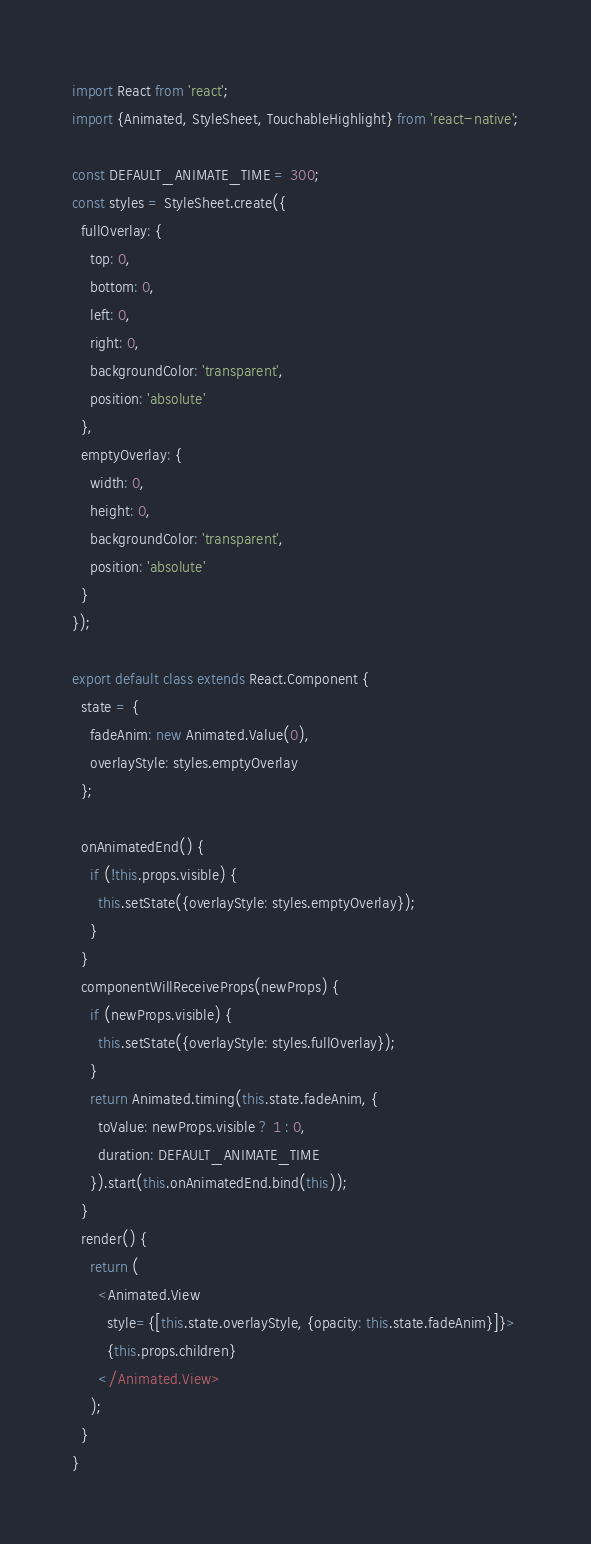Convert code to text. <code><loc_0><loc_0><loc_500><loc_500><_JavaScript_>import React from 'react';
import {Animated, StyleSheet, TouchableHighlight} from 'react-native';

const DEFAULT_ANIMATE_TIME = 300;
const styles = StyleSheet.create({
  fullOverlay: {
    top: 0,
    bottom: 0,
    left: 0,
    right: 0,
    backgroundColor: 'transparent',
    position: 'absolute'
  },
  emptyOverlay: {
    width: 0,
    height: 0,
    backgroundColor: 'transparent',
    position: 'absolute'
  }
});

export default class extends React.Component {
  state = {
    fadeAnim: new Animated.Value(0),
    overlayStyle: styles.emptyOverlay
  };

  onAnimatedEnd() {
    if (!this.props.visible) {
      this.setState({overlayStyle: styles.emptyOverlay});
    }
  }
  componentWillReceiveProps(newProps) {
    if (newProps.visible) {
      this.setState({overlayStyle: styles.fullOverlay});
    }
    return Animated.timing(this.state.fadeAnim, {
      toValue: newProps.visible ? 1 : 0,
      duration: DEFAULT_ANIMATE_TIME
    }).start(this.onAnimatedEnd.bind(this));
  }
  render() {
    return (
      <Animated.View
        style={[this.state.overlayStyle, {opacity: this.state.fadeAnim}]}>
        {this.props.children}
      </Animated.View>
    );
  }
}
</code> 